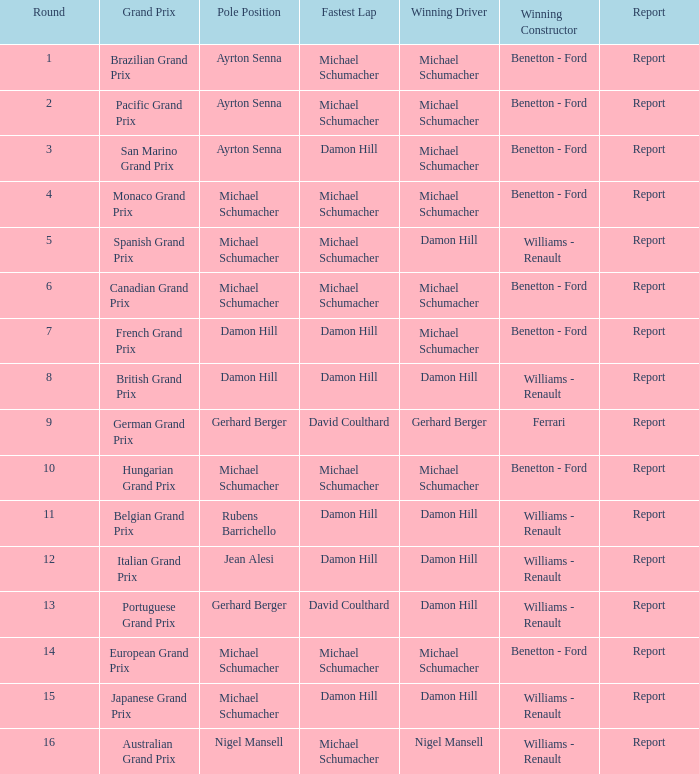Name the pole position at the japanese grand prix when the fastest lap is damon hill Michael Schumacher. 